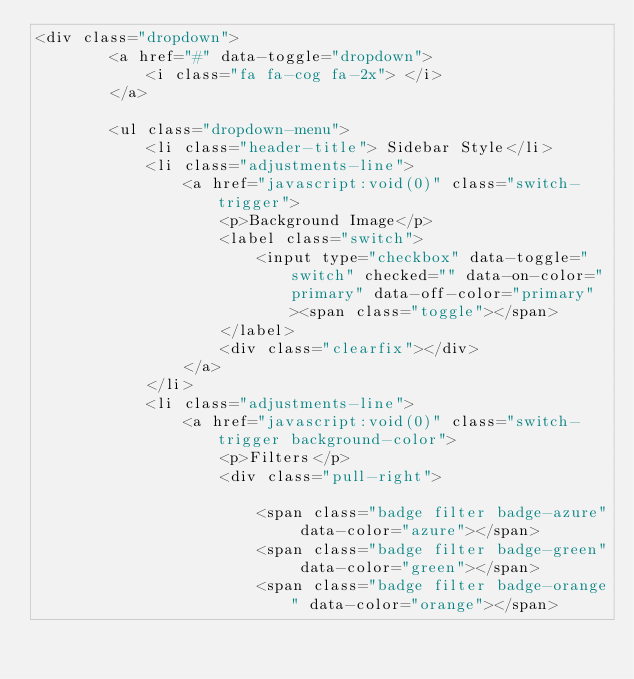Convert code to text. <code><loc_0><loc_0><loc_500><loc_500><_PHP_><div class="dropdown">
        <a href="#" data-toggle="dropdown">
            <i class="fa fa-cog fa-2x"> </i>
        </a>

        <ul class="dropdown-menu">
			<li class="header-title"> Sidebar Style</li>
            <li class="adjustments-line">
                <a href="javascript:void(0)" class="switch-trigger">
                    <p>Background Image</p>
                    <label class="switch">
                        <input type="checkbox" data-toggle="switch" checked="" data-on-color="primary" data-off-color="primary"><span class="toggle"></span>
                    </label>
                    <div class="clearfix"></div>
                </a>
            </li>
            <li class="adjustments-line">
                <a href="javascript:void(0)" class="switch-trigger background-color">
                    <p>Filters</p>
                    <div class="pull-right">
                        
                        <span class="badge filter badge-azure" data-color="azure"></span>
                        <span class="badge filter badge-green" data-color="green"></span>
                        <span class="badge filter badge-orange" data-color="orange"></span></code> 